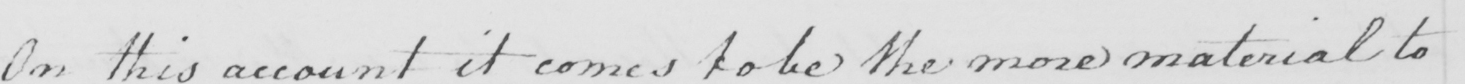Please transcribe the handwritten text in this image. On this account it comes to be the more material to 